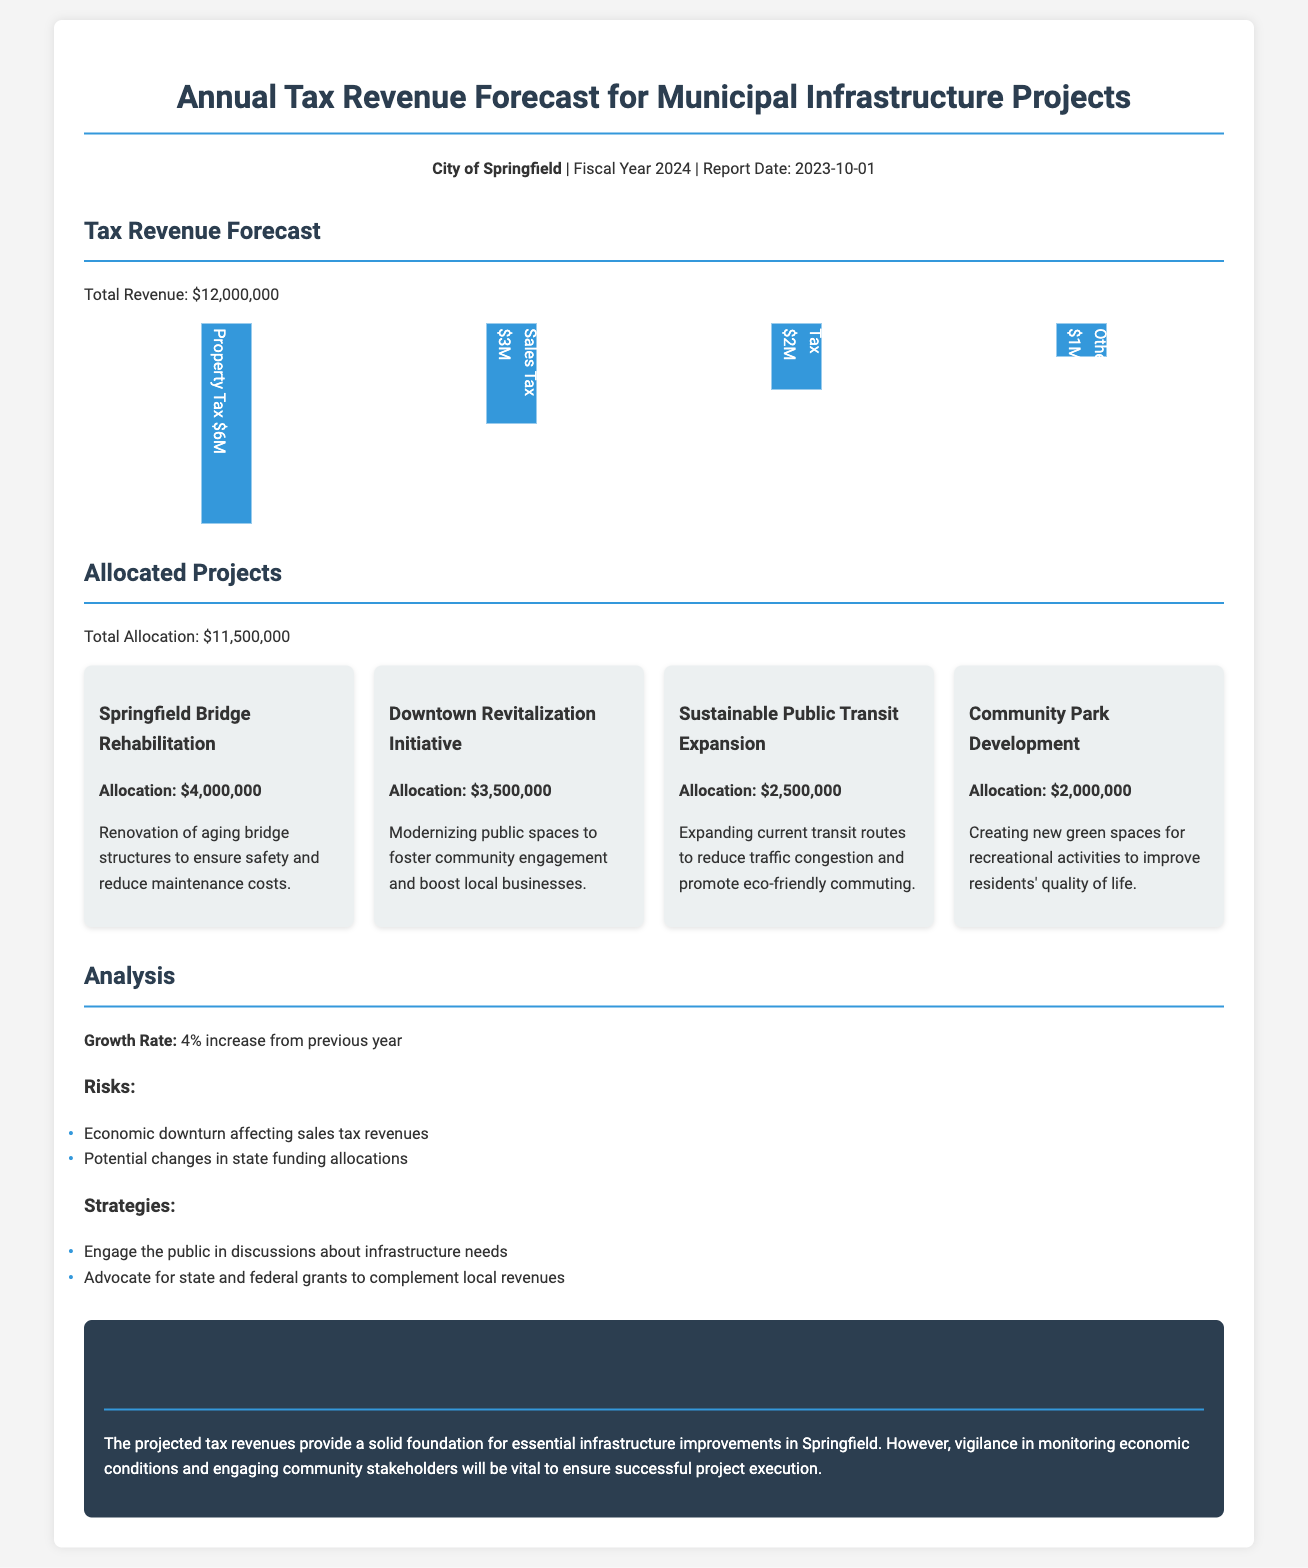What is the total revenue? The total revenue is stated in the document as $12,000,000.
Answer: $12,000,000 How much is allocated for Springfield Bridge Rehabilitation? The document specifies that Springfield Bridge Rehabilitation has an allocation of $4,000,000.
Answer: $4,000,000 What is the growth rate compared to the previous year? The growth rate mentioned in the document is a 4% increase from the previous year.
Answer: 4% What is the total allocation for all projects? The total allocation for all the projects can be found in the document, which is $11,500,000.
Answer: $11,500,000 How much revenue does Sales Tax contribute? The document indicates that Sales Tax contributes $3,000,000 to the total revenue.
Answer: $3,000,000 What are the two identified risks? The risks stated are "Economic downturn affecting sales tax revenues" and "Potential changes in state funding allocations."
Answer: Economic downturn affecting sales tax revenues; Potential changes in state funding allocations Which project has the largest allocation? According to the document, the project with the largest allocation is Springfield Bridge Rehabilitation at $4,000,000.
Answer: Springfield Bridge Rehabilitation What is one strategy mentioned in the report? The report outlines strategies, one of which is "Engage the public in discussions about infrastructure needs."
Answer: Engage the public in discussions about infrastructure needs What is the date of the report? The date of the report is specified in the document as 2023-10-01.
Answer: 2023-10-01 